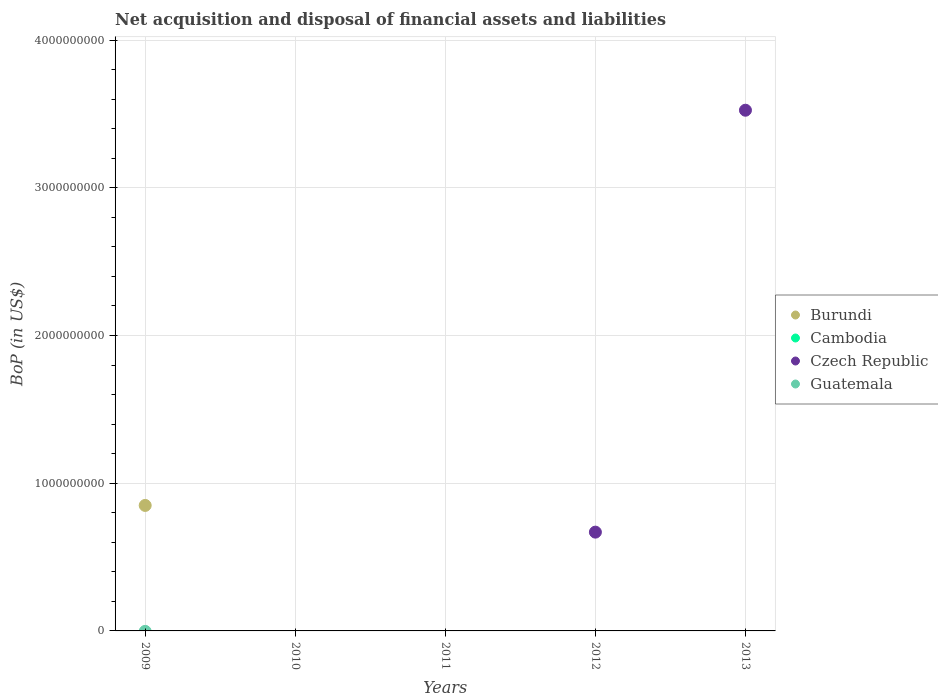How many different coloured dotlines are there?
Make the answer very short. 2. What is the Balance of Payments in Cambodia in 2009?
Offer a very short reply. 0. Across all years, what is the maximum Balance of Payments in Czech Republic?
Your answer should be compact. 3.52e+09. What is the difference between the Balance of Payments in Guatemala in 2011 and the Balance of Payments in Burundi in 2009?
Give a very brief answer. -8.49e+08. In how many years, is the Balance of Payments in Guatemala greater than 1800000000 US$?
Ensure brevity in your answer.  0. What is the difference between the highest and the lowest Balance of Payments in Burundi?
Your answer should be compact. 8.49e+08. In how many years, is the Balance of Payments in Czech Republic greater than the average Balance of Payments in Czech Republic taken over all years?
Make the answer very short. 1. Is it the case that in every year, the sum of the Balance of Payments in Cambodia and Balance of Payments in Czech Republic  is greater than the Balance of Payments in Guatemala?
Offer a terse response. No. Does the Balance of Payments in Czech Republic monotonically increase over the years?
Give a very brief answer. No. Is the Balance of Payments in Burundi strictly greater than the Balance of Payments in Cambodia over the years?
Your response must be concise. No. How many dotlines are there?
Your answer should be compact. 2. Does the graph contain grids?
Your answer should be very brief. Yes. Where does the legend appear in the graph?
Offer a terse response. Center right. How many legend labels are there?
Your answer should be very brief. 4. How are the legend labels stacked?
Provide a succinct answer. Vertical. What is the title of the graph?
Ensure brevity in your answer.  Net acquisition and disposal of financial assets and liabilities. What is the label or title of the Y-axis?
Keep it short and to the point. BoP (in US$). What is the BoP (in US$) of Burundi in 2009?
Give a very brief answer. 8.49e+08. What is the BoP (in US$) of Guatemala in 2009?
Offer a very short reply. 0. What is the BoP (in US$) in Cambodia in 2010?
Provide a succinct answer. 0. What is the BoP (in US$) in Czech Republic in 2010?
Provide a succinct answer. 0. What is the BoP (in US$) of Cambodia in 2011?
Your answer should be very brief. 0. What is the BoP (in US$) of Czech Republic in 2012?
Provide a short and direct response. 6.69e+08. What is the BoP (in US$) in Guatemala in 2012?
Your response must be concise. 0. What is the BoP (in US$) in Burundi in 2013?
Ensure brevity in your answer.  0. What is the BoP (in US$) of Czech Republic in 2013?
Provide a succinct answer. 3.52e+09. Across all years, what is the maximum BoP (in US$) in Burundi?
Provide a short and direct response. 8.49e+08. Across all years, what is the maximum BoP (in US$) in Czech Republic?
Your answer should be compact. 3.52e+09. Across all years, what is the minimum BoP (in US$) of Burundi?
Provide a succinct answer. 0. Across all years, what is the minimum BoP (in US$) of Czech Republic?
Offer a terse response. 0. What is the total BoP (in US$) of Burundi in the graph?
Provide a succinct answer. 8.49e+08. What is the total BoP (in US$) in Czech Republic in the graph?
Provide a succinct answer. 4.19e+09. What is the total BoP (in US$) of Guatemala in the graph?
Give a very brief answer. 0. What is the difference between the BoP (in US$) in Czech Republic in 2012 and that in 2013?
Ensure brevity in your answer.  -2.86e+09. What is the difference between the BoP (in US$) of Burundi in 2009 and the BoP (in US$) of Czech Republic in 2012?
Ensure brevity in your answer.  1.81e+08. What is the difference between the BoP (in US$) of Burundi in 2009 and the BoP (in US$) of Czech Republic in 2013?
Your answer should be compact. -2.68e+09. What is the average BoP (in US$) in Burundi per year?
Your answer should be compact. 1.70e+08. What is the average BoP (in US$) of Cambodia per year?
Make the answer very short. 0. What is the average BoP (in US$) in Czech Republic per year?
Make the answer very short. 8.39e+08. What is the ratio of the BoP (in US$) of Czech Republic in 2012 to that in 2013?
Your response must be concise. 0.19. What is the difference between the highest and the lowest BoP (in US$) of Burundi?
Your answer should be compact. 8.49e+08. What is the difference between the highest and the lowest BoP (in US$) of Czech Republic?
Provide a short and direct response. 3.52e+09. 